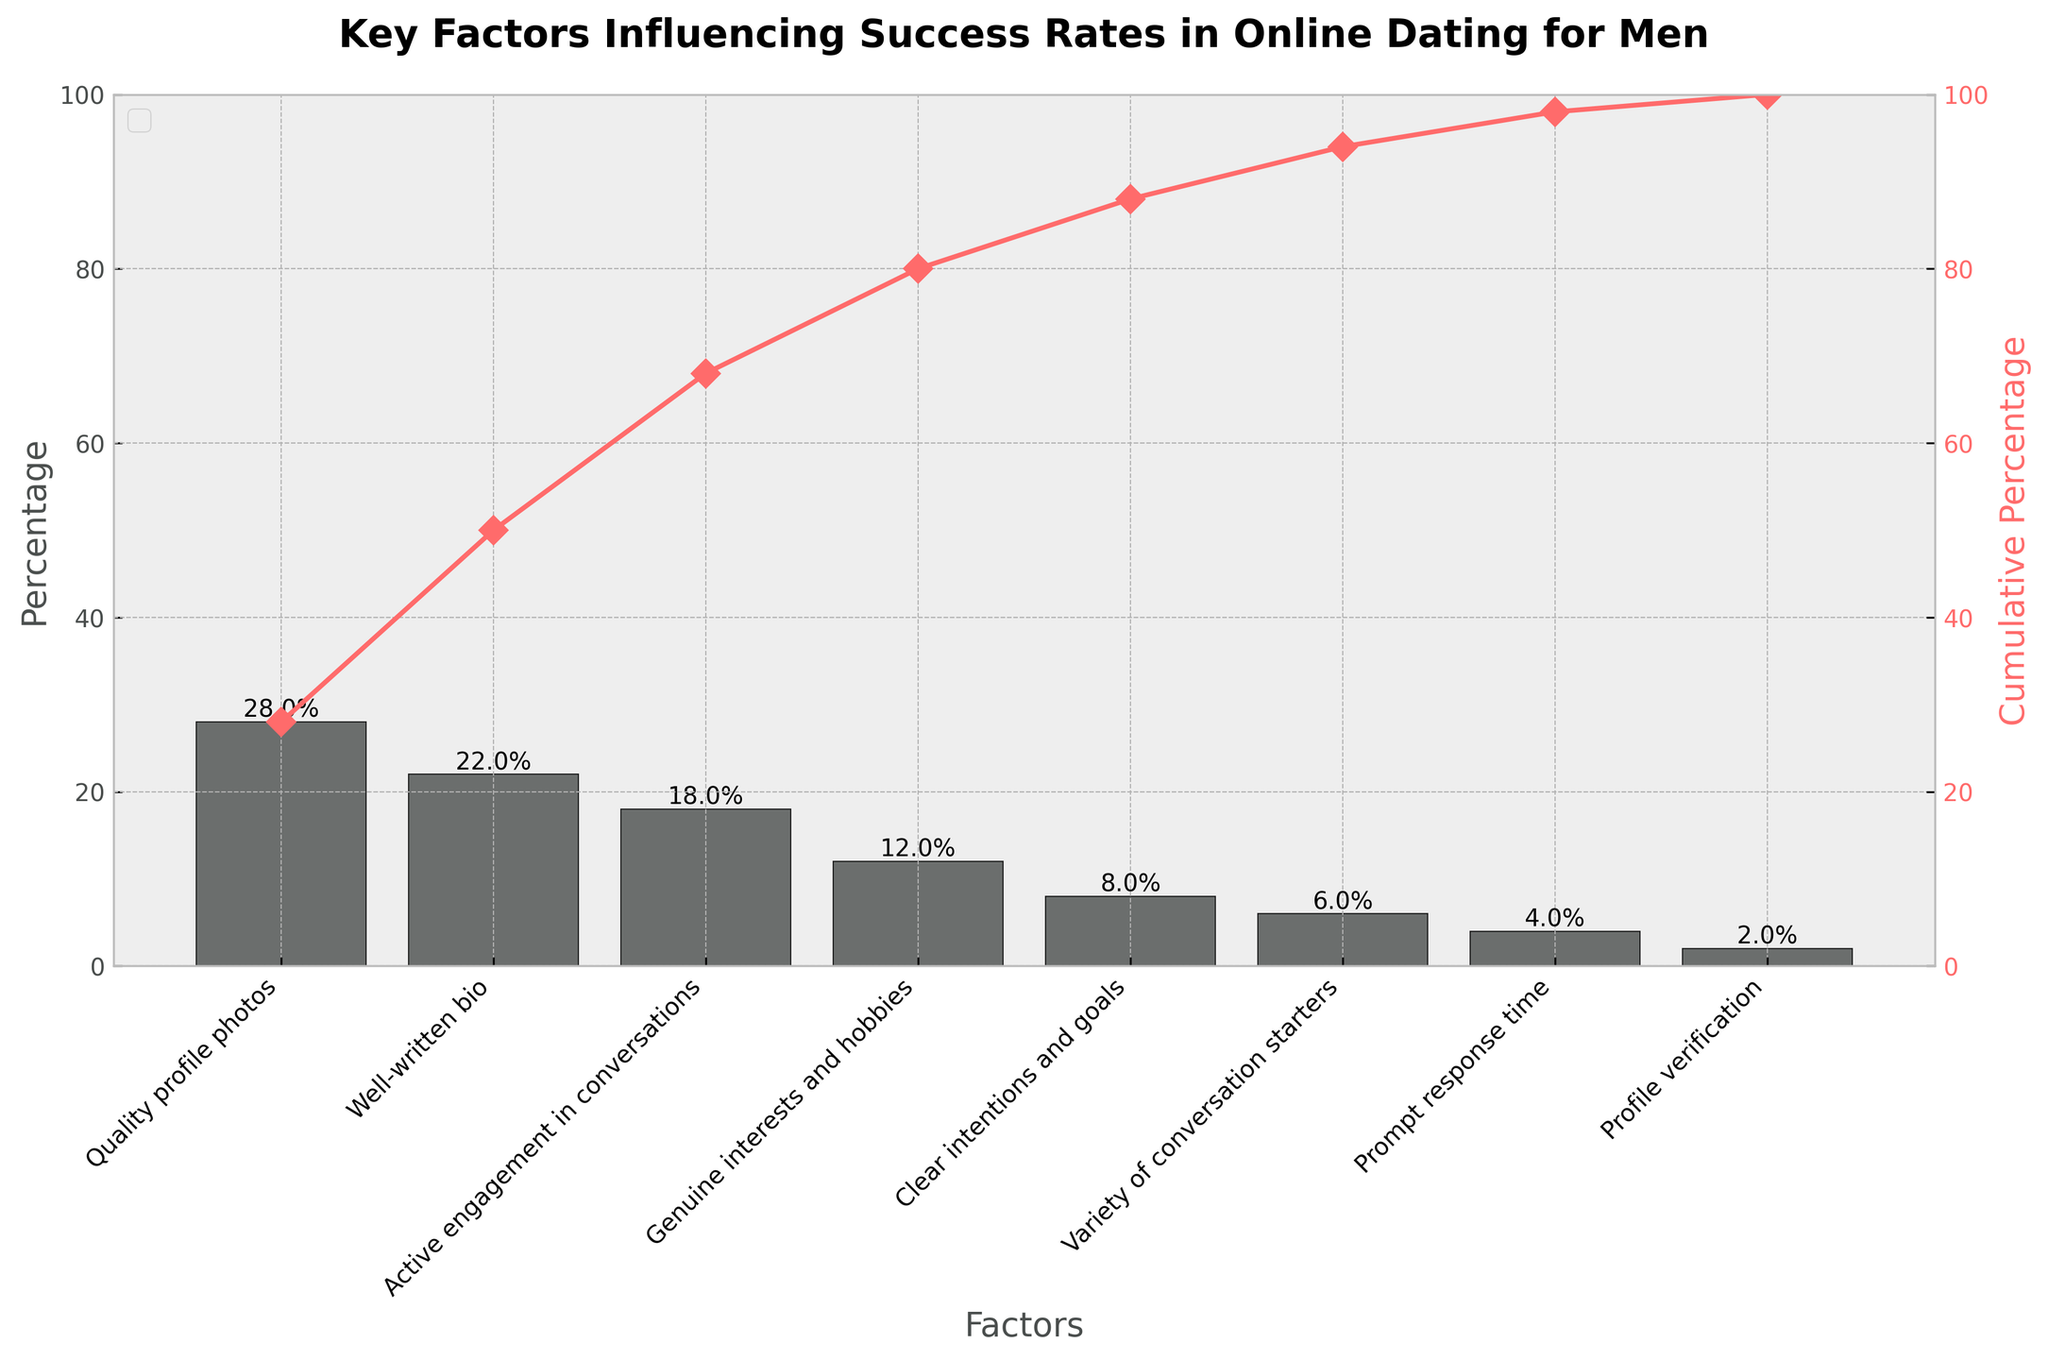What is the title of the chart? The title is displayed at the top of the chart, above the factors and percentages. It reads "Key Factors Influencing Success Rates in Online Dating for Men".
Answer: Key Factors Influencing Success Rates in Online Dating for Men What factor has the highest influence on success rates? The factor with the highest influence is the one with the tallest bar in the bar chart. The tallest bar represents "Quality profile photos".
Answer: Quality profile photos Which factors contribute to at least 70% of the success rates cumulatively? The cumulative line chart helps to see which factors combine to reach 70%. Adding up "Quality profile photos" (28%), "Well-written bio" (22%), "Active engagement in conversations" (18%), and "Genuine interests and hobbies" (12%) gives a cumulative percentage of 80%.
Answer: Quality profile photos, Well-written bio, Active engagement in conversations, Genuine interests and hobbies What's the percentage contribution of "Prompt response time"? The bar corresponding to "Prompt response time" gives its percentage directly. It is one of the smaller bars towards the end.
Answer: 4% How much more influential is "Quality profile photos" compared to "Prompt response time"? The height of "Quality profile photos" bar is 28% and for "Prompt response time" is 4%. The difference between these percentages is 28% - 4%.
Answer: 24% How many factors have a percentage higher than 10%? By examining the height of the bars and their corresponding percentages, the bars over 10% are: "Quality profile photos" (28%), "Well-written bio" (22%), "Active engagement in conversations" (18%), and "Genuine interests and hobbies" (12%).
Answer: 4 If you combine the percentage of "Variety of conversation starters" and "Profile verification," what do you get? Adding the percentages for "Variety of conversation starters" (6%) and "Profile verification" (2%) results in 6% + 2%.
Answer: 8% Which factor contributes the least to success rates? The bar with the smallest height indicates the least contribution, which in this case is "Profile verification".
Answer: Profile verification If a new factor were added with a 5% influence, how would that change the cumulative percentage for the top 3 factors? Adding a new factor with 5% would affect the layout but not the cumulative line of existing factors. The top 3 factors already sum to 68% ("Quality profile photos" 28%, "Well-written bio" 22%, "Active engagement in conversations" 18%). Adding 5% to this total 68% would result in 68% + 5%.
Answer: 73% What's the difference in percentage points between "Clear intentions and goals" and "Genuine interests and hobbies"? Subtract the percentage of "Clear intentions and goals" (8%) from that of "Genuine interests and hobbies" (12%).
Answer: 4% 